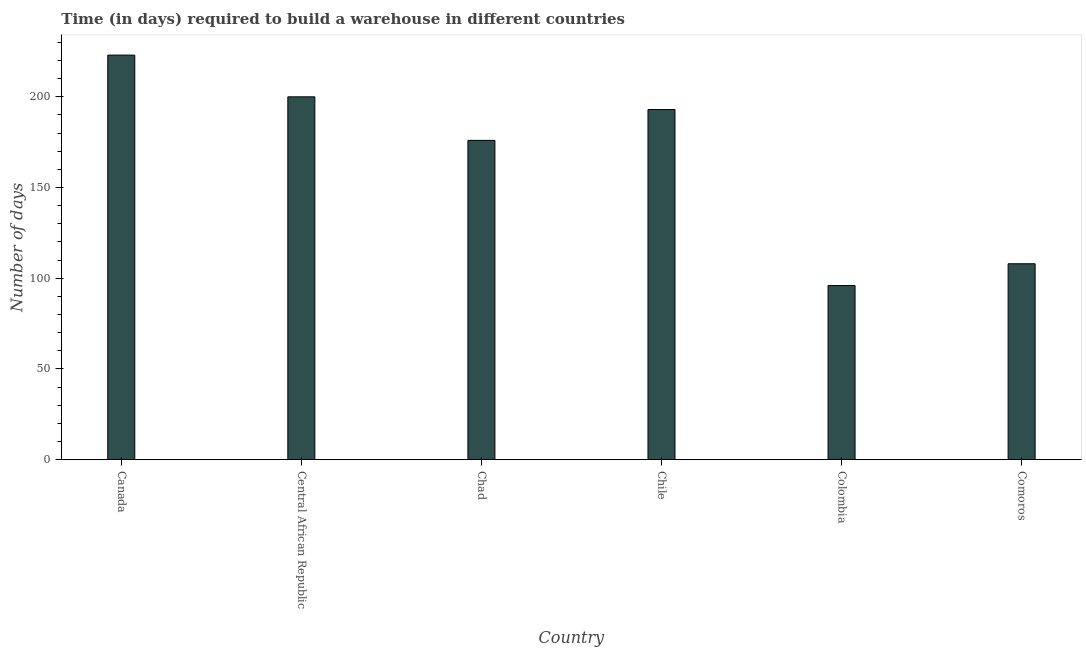Does the graph contain grids?
Ensure brevity in your answer.  No. What is the title of the graph?
Make the answer very short. Time (in days) required to build a warehouse in different countries. What is the label or title of the X-axis?
Ensure brevity in your answer.  Country. What is the label or title of the Y-axis?
Give a very brief answer. Number of days. Across all countries, what is the maximum time required to build a warehouse?
Provide a short and direct response. 223. Across all countries, what is the minimum time required to build a warehouse?
Your answer should be compact. 96. In which country was the time required to build a warehouse minimum?
Your answer should be very brief. Colombia. What is the sum of the time required to build a warehouse?
Your answer should be compact. 996. What is the difference between the time required to build a warehouse in Canada and Chile?
Give a very brief answer. 30. What is the average time required to build a warehouse per country?
Give a very brief answer. 166. What is the median time required to build a warehouse?
Provide a succinct answer. 184.5. In how many countries, is the time required to build a warehouse greater than 150 days?
Provide a short and direct response. 4. What is the ratio of the time required to build a warehouse in Canada to that in Central African Republic?
Give a very brief answer. 1.11. Is the difference between the time required to build a warehouse in Canada and Central African Republic greater than the difference between any two countries?
Provide a succinct answer. No. What is the difference between the highest and the lowest time required to build a warehouse?
Your answer should be very brief. 127. How many bars are there?
Your response must be concise. 6. How many countries are there in the graph?
Make the answer very short. 6. Are the values on the major ticks of Y-axis written in scientific E-notation?
Your answer should be compact. No. What is the Number of days of Canada?
Your response must be concise. 223. What is the Number of days of Central African Republic?
Offer a very short reply. 200. What is the Number of days in Chad?
Keep it short and to the point. 176. What is the Number of days in Chile?
Keep it short and to the point. 193. What is the Number of days in Colombia?
Your response must be concise. 96. What is the Number of days of Comoros?
Your answer should be very brief. 108. What is the difference between the Number of days in Canada and Central African Republic?
Your answer should be very brief. 23. What is the difference between the Number of days in Canada and Colombia?
Provide a succinct answer. 127. What is the difference between the Number of days in Canada and Comoros?
Make the answer very short. 115. What is the difference between the Number of days in Central African Republic and Chad?
Ensure brevity in your answer.  24. What is the difference between the Number of days in Central African Republic and Chile?
Give a very brief answer. 7. What is the difference between the Number of days in Central African Republic and Colombia?
Make the answer very short. 104. What is the difference between the Number of days in Central African Republic and Comoros?
Your response must be concise. 92. What is the difference between the Number of days in Chad and Chile?
Offer a terse response. -17. What is the difference between the Number of days in Chad and Colombia?
Make the answer very short. 80. What is the difference between the Number of days in Chad and Comoros?
Keep it short and to the point. 68. What is the difference between the Number of days in Chile and Colombia?
Ensure brevity in your answer.  97. What is the ratio of the Number of days in Canada to that in Central African Republic?
Offer a terse response. 1.11. What is the ratio of the Number of days in Canada to that in Chad?
Provide a short and direct response. 1.27. What is the ratio of the Number of days in Canada to that in Chile?
Make the answer very short. 1.16. What is the ratio of the Number of days in Canada to that in Colombia?
Keep it short and to the point. 2.32. What is the ratio of the Number of days in Canada to that in Comoros?
Offer a terse response. 2.06. What is the ratio of the Number of days in Central African Republic to that in Chad?
Provide a succinct answer. 1.14. What is the ratio of the Number of days in Central African Republic to that in Chile?
Keep it short and to the point. 1.04. What is the ratio of the Number of days in Central African Republic to that in Colombia?
Give a very brief answer. 2.08. What is the ratio of the Number of days in Central African Republic to that in Comoros?
Offer a terse response. 1.85. What is the ratio of the Number of days in Chad to that in Chile?
Your answer should be very brief. 0.91. What is the ratio of the Number of days in Chad to that in Colombia?
Make the answer very short. 1.83. What is the ratio of the Number of days in Chad to that in Comoros?
Keep it short and to the point. 1.63. What is the ratio of the Number of days in Chile to that in Colombia?
Provide a short and direct response. 2.01. What is the ratio of the Number of days in Chile to that in Comoros?
Offer a terse response. 1.79. What is the ratio of the Number of days in Colombia to that in Comoros?
Your answer should be compact. 0.89. 